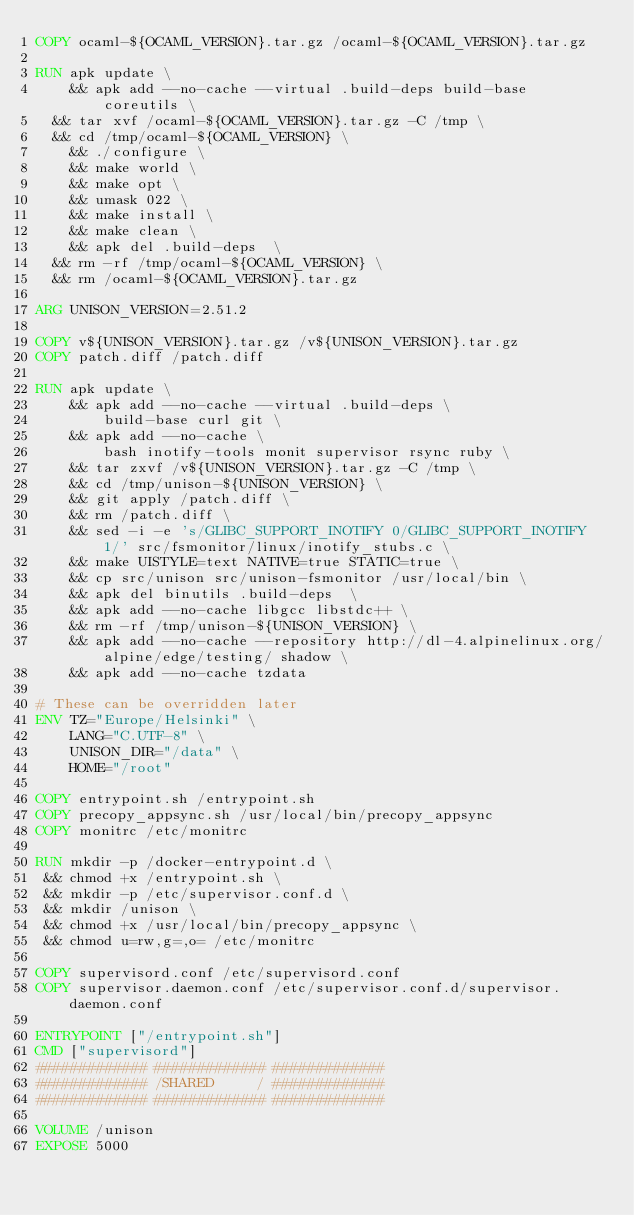Convert code to text. <code><loc_0><loc_0><loc_500><loc_500><_Dockerfile_>COPY ocaml-${OCAML_VERSION}.tar.gz /ocaml-${OCAML_VERSION}.tar.gz

RUN apk update \
    && apk add --no-cache --virtual .build-deps build-base coreutils \
	&& tar xvf /ocaml-${OCAML_VERSION}.tar.gz -C /tmp \
	&& cd /tmp/ocaml-${OCAML_VERSION} \
    && ./configure \
    && make world \
    && make opt \
    && umask 022 \
    && make install \
    && make clean \
    && apk del .build-deps  \
	&& rm -rf /tmp/ocaml-${OCAML_VERSION} \
	&& rm /ocaml-${OCAML_VERSION}.tar.gz

ARG UNISON_VERSION=2.51.2

COPY v${UNISON_VERSION}.tar.gz /v${UNISON_VERSION}.tar.gz
COPY patch.diff /patch.diff

RUN apk update \
    && apk add --no-cache --virtual .build-deps \
        build-base curl git \
    && apk add --no-cache \
        bash inotify-tools monit supervisor rsync ruby \
    && tar zxvf /v${UNISON_VERSION}.tar.gz -C /tmp \
    && cd /tmp/unison-${UNISON_VERSION} \
    && git apply /patch.diff \
    && rm /patch.diff \
    && sed -i -e 's/GLIBC_SUPPORT_INOTIFY 0/GLIBC_SUPPORT_INOTIFY 1/' src/fsmonitor/linux/inotify_stubs.c \
    && make UISTYLE=text NATIVE=true STATIC=true \
    && cp src/unison src/unison-fsmonitor /usr/local/bin \
    && apk del binutils .build-deps  \
    && apk add --no-cache libgcc libstdc++ \
    && rm -rf /tmp/unison-${UNISON_VERSION} \
    && apk add --no-cache --repository http://dl-4.alpinelinux.org/alpine/edge/testing/ shadow \
    && apk add --no-cache tzdata

# These can be overridden later
ENV TZ="Europe/Helsinki" \
    LANG="C.UTF-8" \
    UNISON_DIR="/data" \
    HOME="/root"

COPY entrypoint.sh /entrypoint.sh
COPY precopy_appsync.sh /usr/local/bin/precopy_appsync
COPY monitrc /etc/monitrc

RUN mkdir -p /docker-entrypoint.d \
 && chmod +x /entrypoint.sh \
 && mkdir -p /etc/supervisor.conf.d \
 && mkdir /unison \
 && chmod +x /usr/local/bin/precopy_appsync \
 && chmod u=rw,g=,o= /etc/monitrc

COPY supervisord.conf /etc/supervisord.conf
COPY supervisor.daemon.conf /etc/supervisor.conf.d/supervisor.daemon.conf

ENTRYPOINT ["/entrypoint.sh"]
CMD ["supervisord"]
############# ############# #############
############# /SHARED     / #############
############# ############# #############

VOLUME /unison
EXPOSE 5000
</code> 